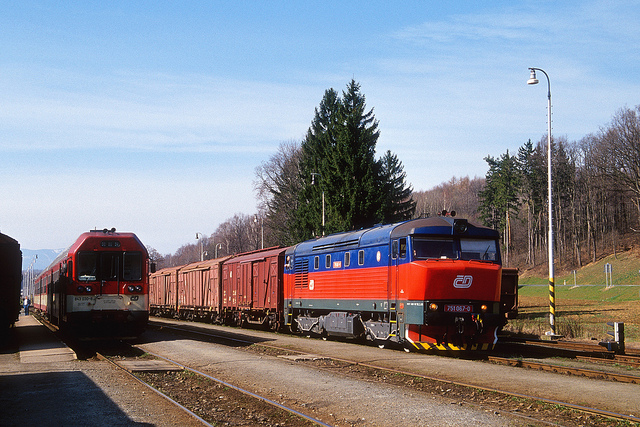Identify and read out the text in this image. 6 